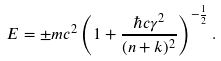<formula> <loc_0><loc_0><loc_500><loc_500>E = \pm m c ^ { 2 } \left ( 1 + \frac { \hbar { c } \gamma ^ { 2 } } { ( n + k ) ^ { 2 } } \right ) ^ { - \frac { 1 } { 2 } } .</formula> 